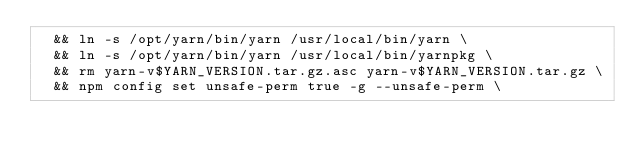Convert code to text. <code><loc_0><loc_0><loc_500><loc_500><_Dockerfile_>	&& ln -s /opt/yarn/bin/yarn /usr/local/bin/yarn \
	&& ln -s /opt/yarn/bin/yarn /usr/local/bin/yarnpkg \
	&& rm yarn-v$YARN_VERSION.tar.gz.asc yarn-v$YARN_VERSION.tar.gz \
	&& npm config set unsafe-perm true -g --unsafe-perm \</code> 